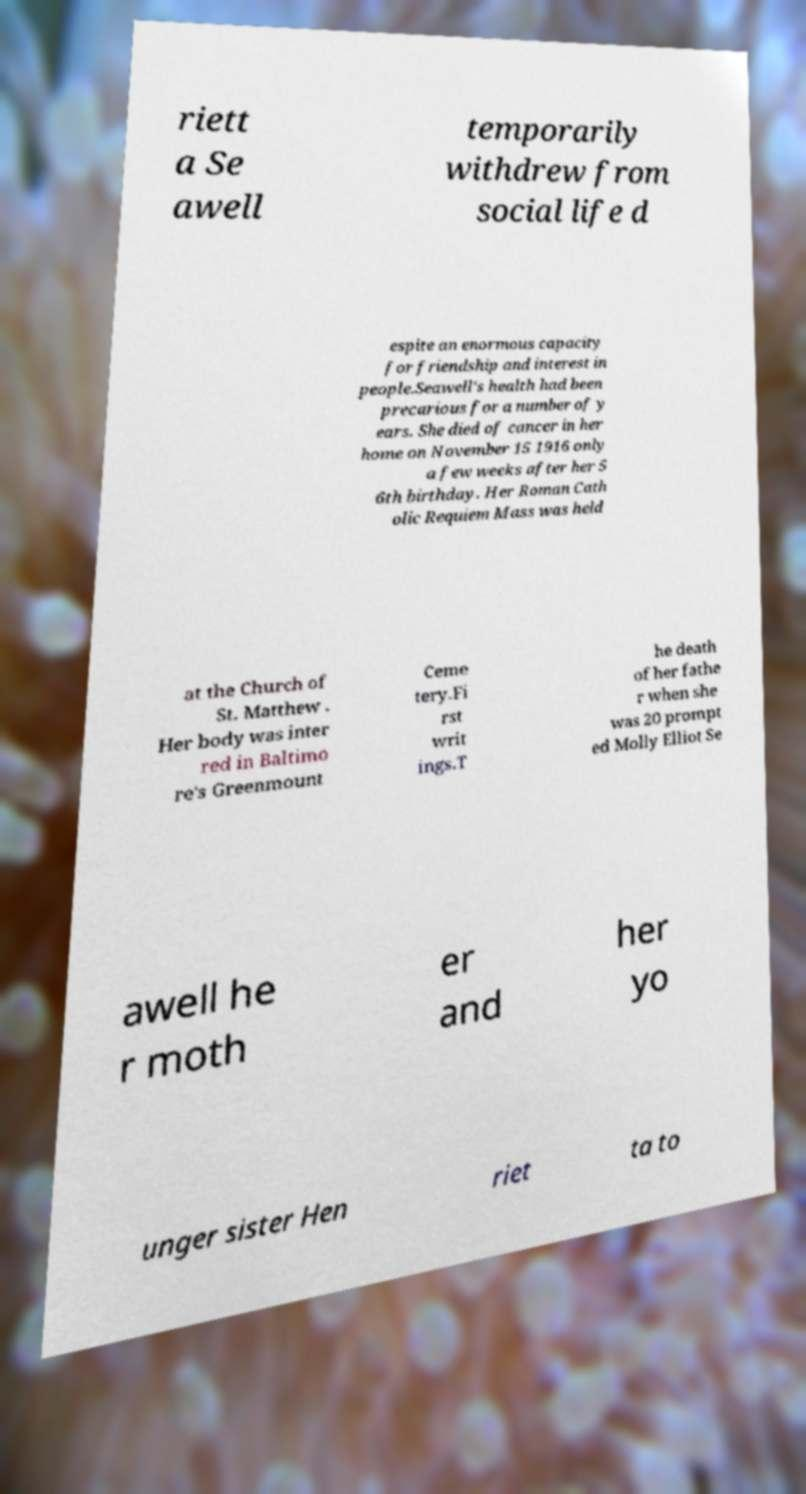I need the written content from this picture converted into text. Can you do that? riett a Se awell temporarily withdrew from social life d espite an enormous capacity for friendship and interest in people.Seawell's health had been precarious for a number of y ears. She died of cancer in her home on November 15 1916 only a few weeks after her 5 6th birthday. Her Roman Cath olic Requiem Mass was held at the Church of St. Matthew . Her body was inter red in Baltimo re's Greenmount Ceme tery.Fi rst writ ings.T he death of her fathe r when she was 20 prompt ed Molly Elliot Se awell he r moth er and her yo unger sister Hen riet ta to 